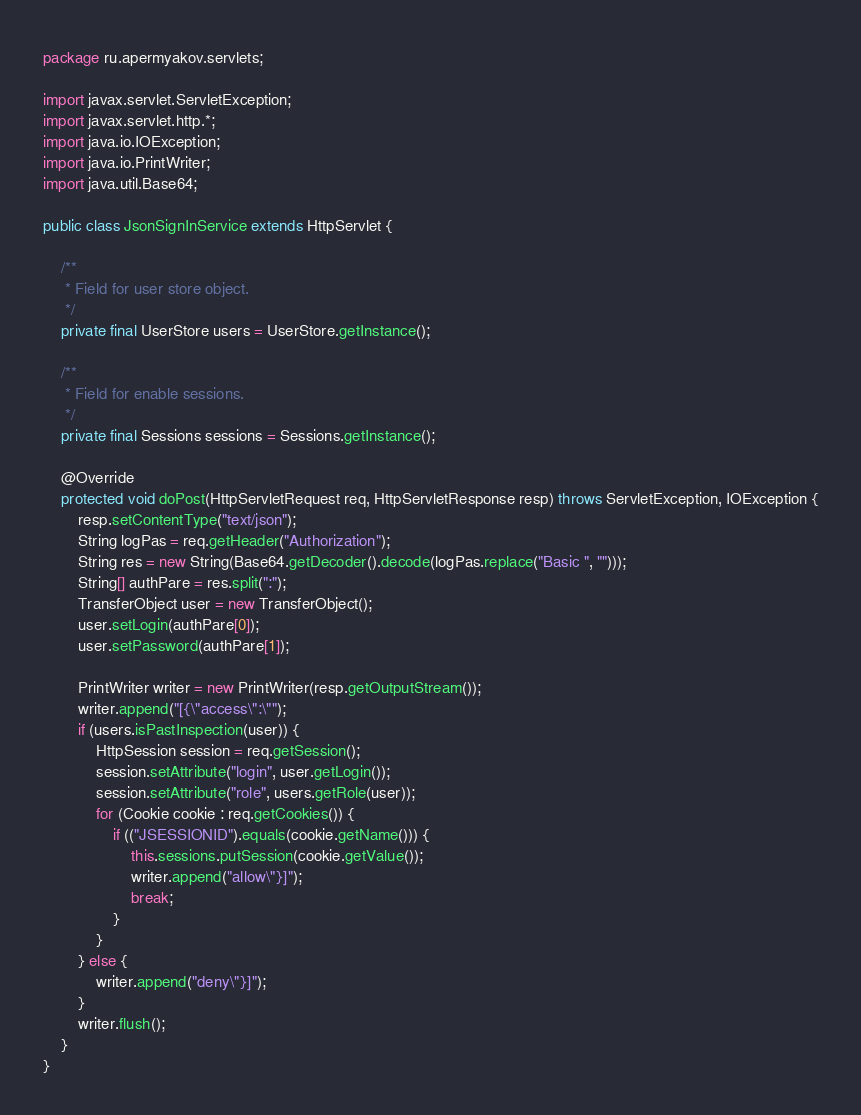<code> <loc_0><loc_0><loc_500><loc_500><_Java_>package ru.apermyakov.servlets;

import javax.servlet.ServletException;
import javax.servlet.http.*;
import java.io.IOException;
import java.io.PrintWriter;
import java.util.Base64;

public class JsonSignInService extends HttpServlet {

    /**
     * Field for user store object.
     */
    private final UserStore users = UserStore.getInstance();

    /**
     * Field for enable sessions.
     */
    private final Sessions sessions = Sessions.getInstance();

    @Override
    protected void doPost(HttpServletRequest req, HttpServletResponse resp) throws ServletException, IOException {
        resp.setContentType("text/json");
        String logPas = req.getHeader("Authorization");
        String res = new String(Base64.getDecoder().decode(logPas.replace("Basic ", "")));
        String[] authPare = res.split(":");
        TransferObject user = new TransferObject();
        user.setLogin(authPare[0]);
        user.setPassword(authPare[1]);

        PrintWriter writer = new PrintWriter(resp.getOutputStream());
        writer.append("[{\"access\":\"");
        if (users.isPastInspection(user)) {
            HttpSession session = req.getSession();
            session.setAttribute("login", user.getLogin());
            session.setAttribute("role", users.getRole(user));
            for (Cookie cookie : req.getCookies()) {
                if (("JSESSIONID").equals(cookie.getName())) {
                    this.sessions.putSession(cookie.getValue());
                    writer.append("allow\"}]");
                    break;
                }
            }
        } else {
            writer.append("deny\"}]");
        }
        writer.flush();
    }
}
</code> 